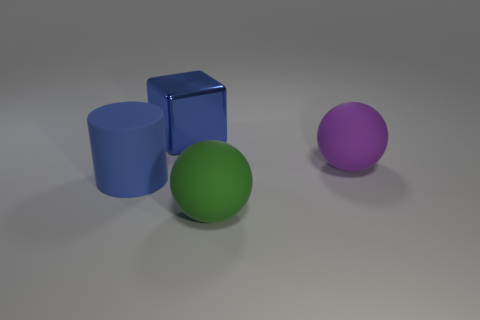Subtract all cyan blocks. Subtract all blue spheres. How many blocks are left? 1 Add 3 rubber balls. How many objects exist? 7 Subtract all cylinders. How many objects are left? 3 Subtract all small purple metal blocks. Subtract all blue blocks. How many objects are left? 3 Add 1 matte things. How many matte things are left? 4 Add 3 large blue matte objects. How many large blue matte objects exist? 4 Subtract 0 cyan balls. How many objects are left? 4 